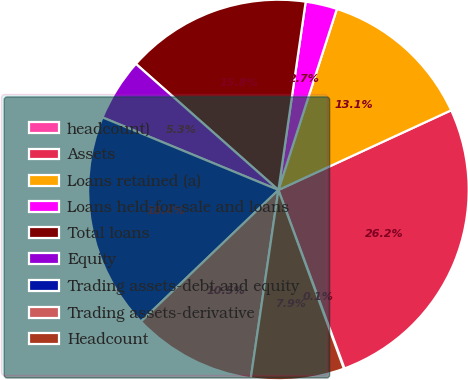<chart> <loc_0><loc_0><loc_500><loc_500><pie_chart><fcel>headcount)<fcel>Assets<fcel>Loans retained (a)<fcel>Loans held-for-sale and loans<fcel>Total loans<fcel>Equity<fcel>Trading assets-debt and equity<fcel>Trading assets-derivative<fcel>Headcount<nl><fcel>0.06%<fcel>26.23%<fcel>13.15%<fcel>2.68%<fcel>15.76%<fcel>5.3%<fcel>18.38%<fcel>10.53%<fcel>7.91%<nl></chart> 